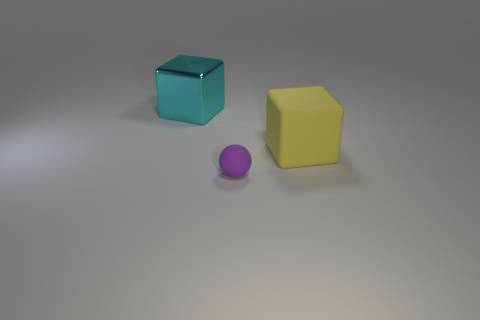Add 3 big yellow matte things. How many objects exist? 6 Subtract all spheres. How many objects are left? 2 Subtract 0 blue blocks. How many objects are left? 3 Subtract all purple rubber blocks. Subtract all metal blocks. How many objects are left? 2 Add 2 cubes. How many cubes are left? 4 Add 1 tiny purple objects. How many tiny purple objects exist? 2 